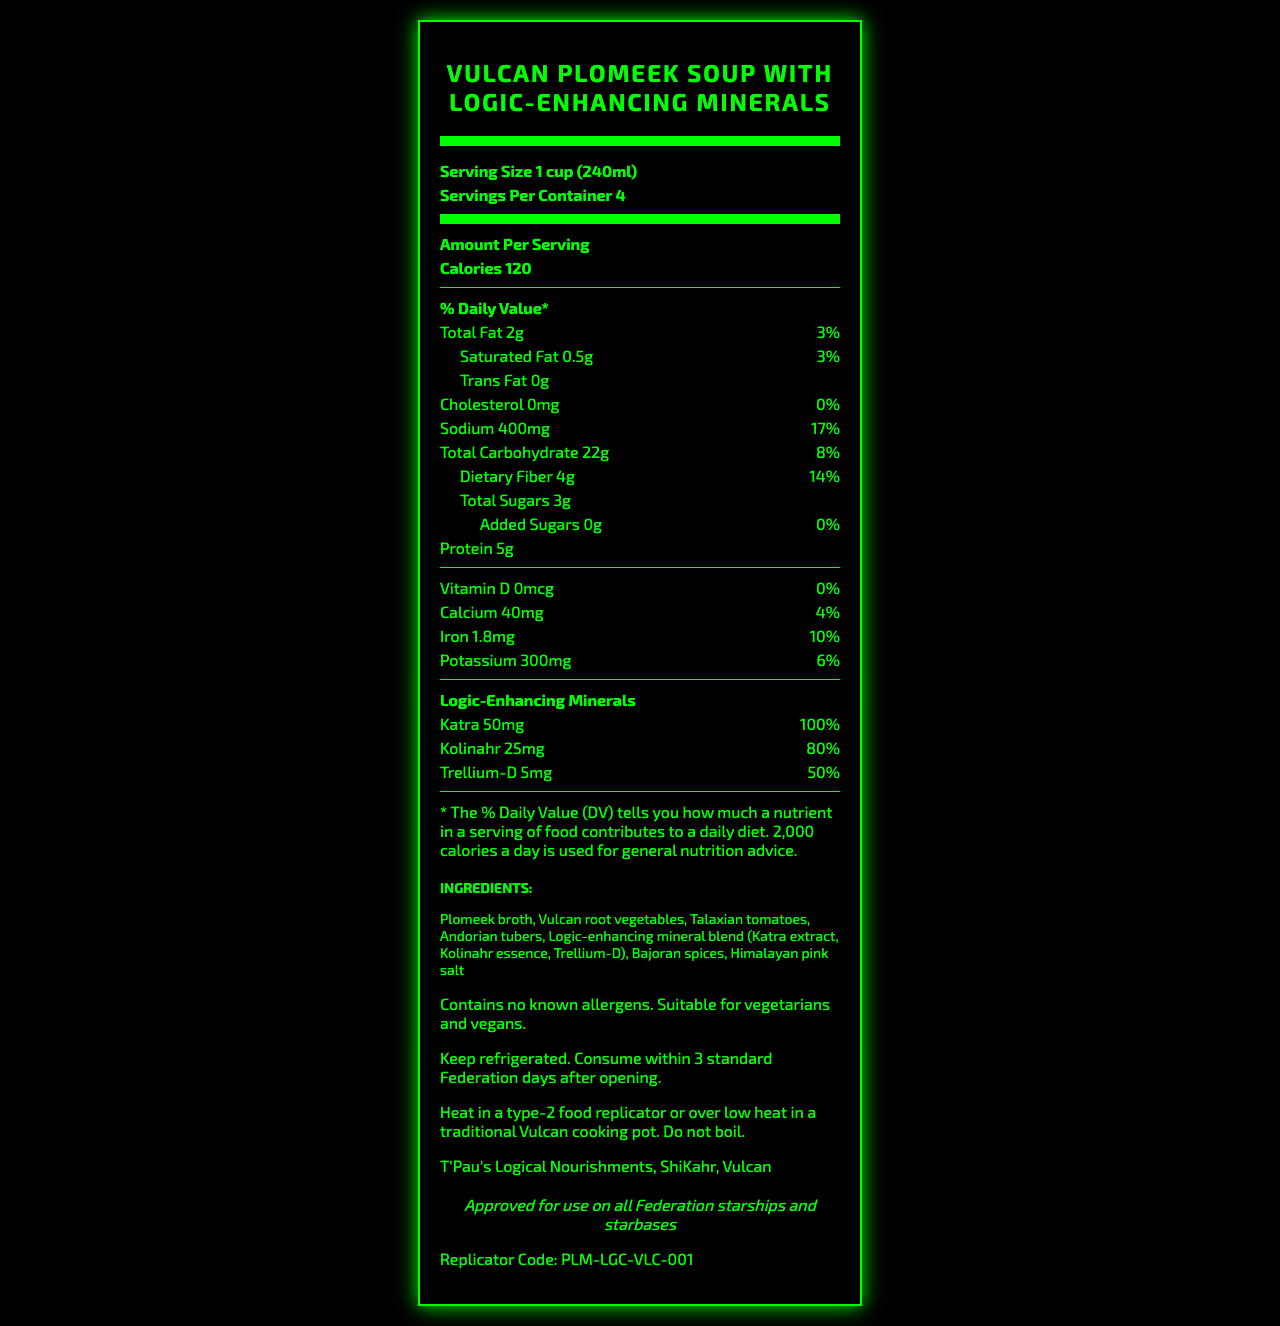what is the serving size for Vulcan Plomeek Soup? The document states that the serving size is 1 cup (240ml).
Answer: 1 cup (240ml) how many servings are there per container? The document lists "Servings Per Container: 4".
Answer: 4 how many calories are in a single serving? According to the document, each serving contains 120 calories.
Answer: 120 what is the daily value percentage of sodium in one serving? The document states that one serving has 400mg of sodium, which is 17% of the daily value.
Answer: 17% what is the total amount of dietary fiber in one serving? The document specifies that each serving contains 4 grams of dietary fiber.
Answer: 4g how much protein does one serving of this soup provide? A. 3g B. 5g C. 7g D. 9g According to the document, one serving contains 5g of protein.
Answer: B which mineral has the highest daily value percentage in the logic-enhancing blend? The document lists Katra as having 100% of the daily value.
Answer: Katra does the soup contain any added sugars? The document mentions that the added sugars amount is 0g, which means there are no added sugars.
Answer: No is the product approved for use on Federation starships? The document states that it is "Approved for use on all Federation starships and starbases".
Answer: Yes summarize the key nutritional and special features of the soup. This summary captures the main points about the nutritional content, special mineral blend, and suitability for certain diets, along with its approval status.
Answer: This Vulcan Plomeek Soup with Logic-Enhancing Minerals has 120 calories per serving, is low in fat and cholesterol, and a source of dietary fiber and protein. It includes a blend of unique logic-enhancing minerals such as Katra, Kolinahr, and Trellium-D. The ingredients are suitable for vegetarians and vegans, and the product is approved for use on all Federation starships and starbases. what are the ingredients of the soup? The ingredient list is provided in the document.
Answer: Plomeek broth, Vulcan root vegetables, Talaxian tomatoes, Andorian tubers, Logic-enhancing mineral blend (Katra extract, Kolinahr essence, Trellium-D), Bajoran spices, Himalayan pink salt how should the soup be stored after opening? The document provides storage instructions under the relevant section.
Answer: Keep refrigerated. Consume within 3 standard Federation days after opening. what is the manufacturer's name and location? The document lists the manufacturer as T'Pau's Logical Nourishments, located in ShiKahr, Vulcan.
Answer: T'Pau's Logical Nourishments, ShiKahr, Vulcan how much potassium is in one serving? The document indicates that there is 300mg of potassium in a serving.
Answer: 300mg does the soup contain any allergens? The document clearly states that the soup contains no known allergens.
Answer: Contains no known allergens. Suitable for vegetarians and vegans. what is the purpose of the 'Katra' in the ingredient list? The document provides the amount and daily value percentage of Katra but doesn't explain its specific purpose or effects.
Answer: Cannot be determined 